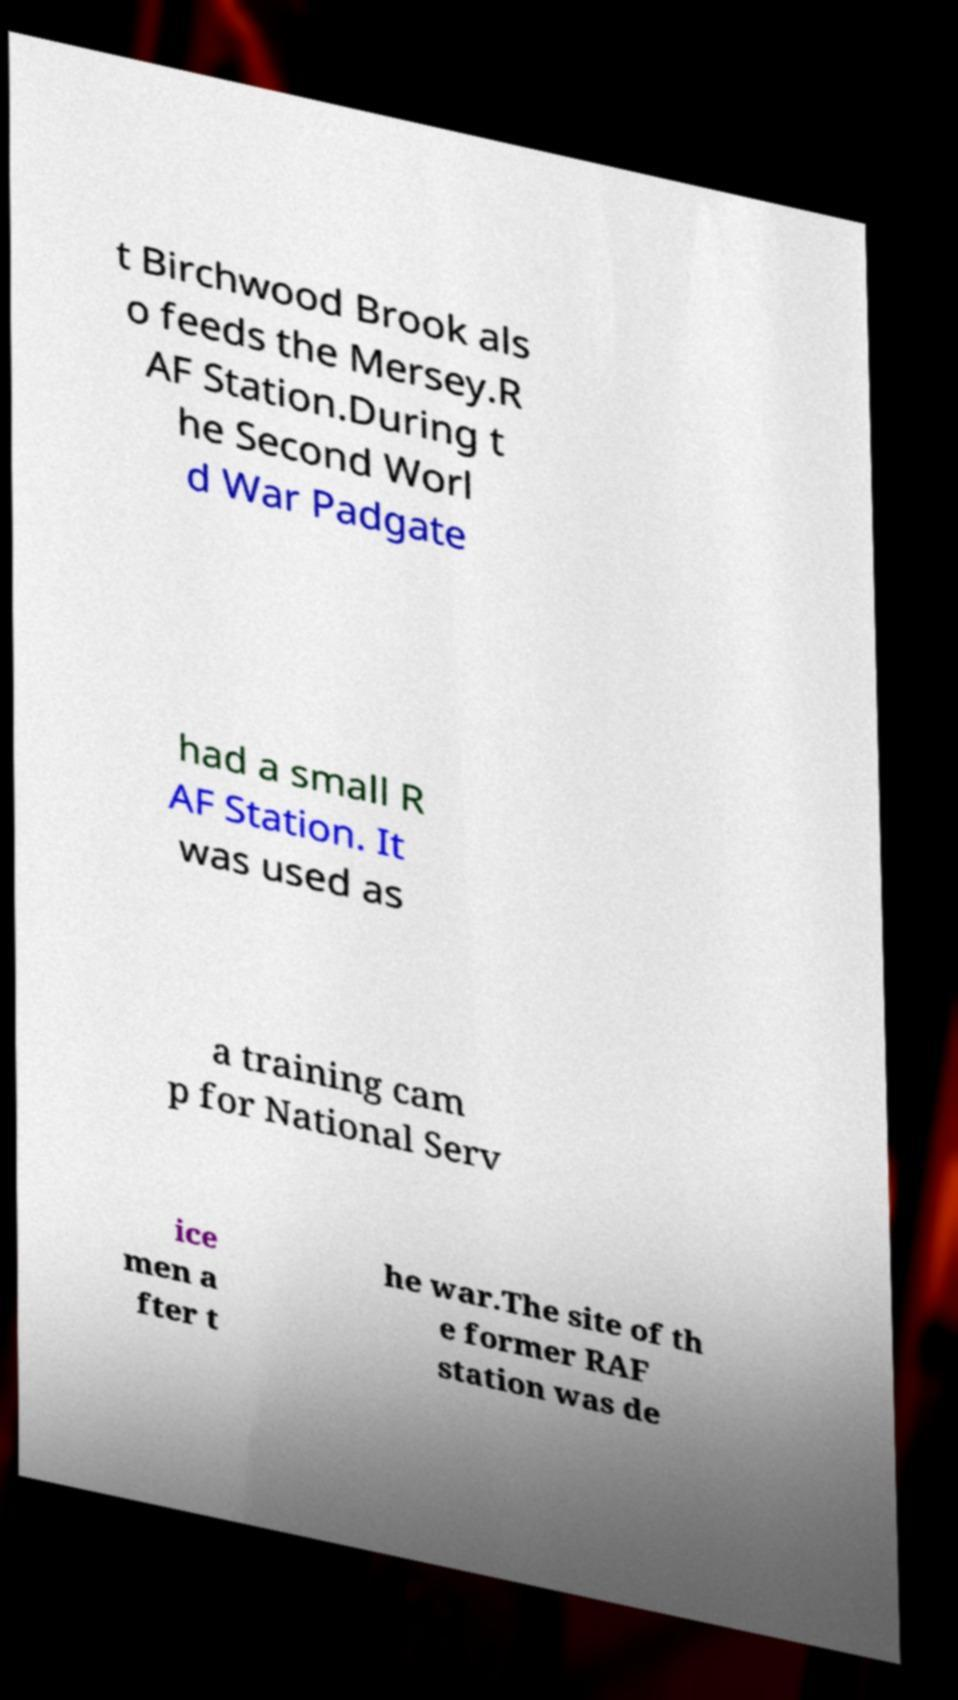Can you accurately transcribe the text from the provided image for me? t Birchwood Brook als o feeds the Mersey.R AF Station.During t he Second Worl d War Padgate had a small R AF Station. It was used as a training cam p for National Serv ice men a fter t he war.The site of th e former RAF station was de 